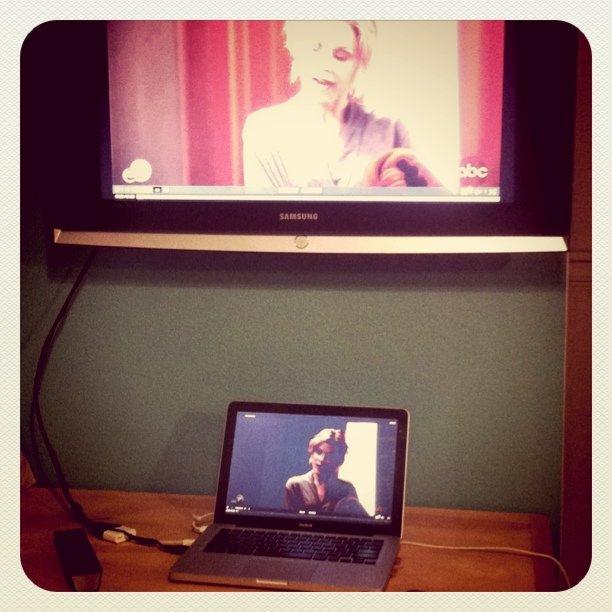Which image of the woman is better quality?
Quick response, please. Bottom. What network is shown on the television?
Concise answer only. Abc. What brand is the TV?
Quick response, please. Samsung. 